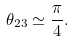<formula> <loc_0><loc_0><loc_500><loc_500>\theta _ { 2 3 } \simeq \frac { \pi } { 4 } .</formula> 